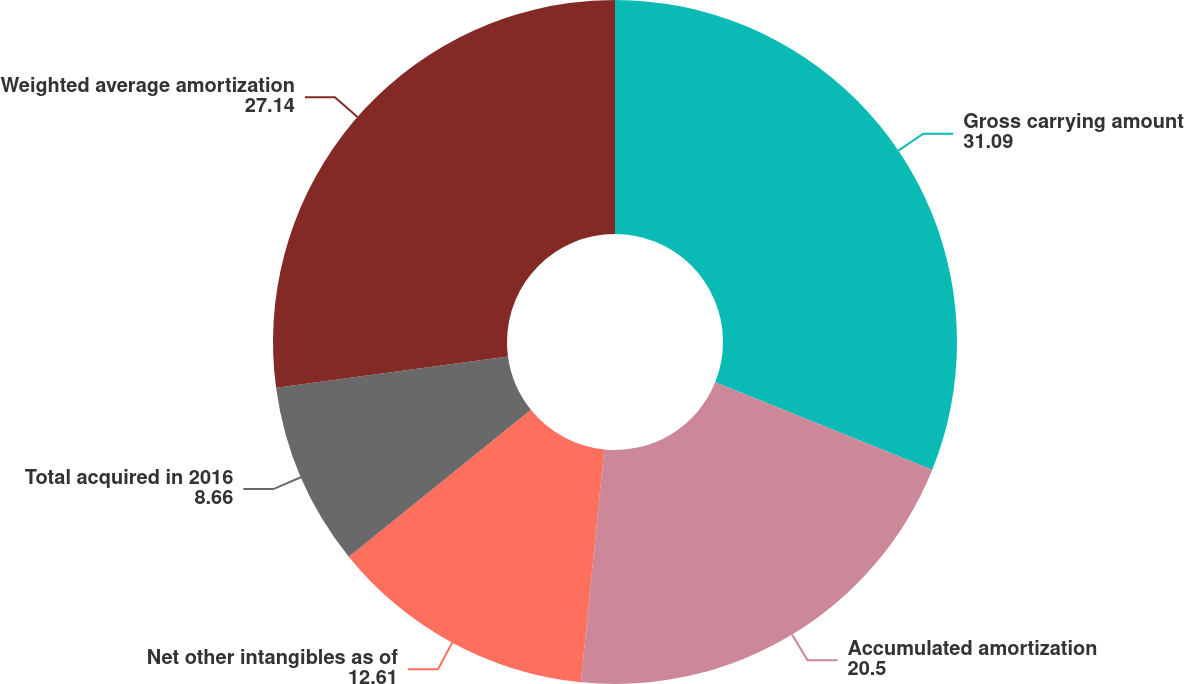<chart> <loc_0><loc_0><loc_500><loc_500><pie_chart><fcel>Gross carrying amount<fcel>Accumulated amortization<fcel>Net other intangibles as of<fcel>Total acquired in 2016<fcel>Weighted average amortization<nl><fcel>31.09%<fcel>20.5%<fcel>12.61%<fcel>8.66%<fcel>27.14%<nl></chart> 